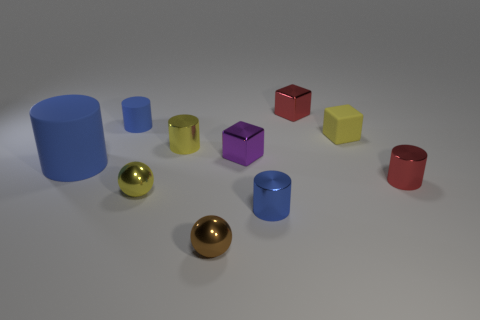Can you tell me more about the arrangement of these shapes? Certainly! The configuration of the objects seems deliberately spaced, with each shape given room to stand out. There's a mix of geometrical figures such as cubes, cylinders, and spheres. Each object showcases a different color and finish, hinting at a study of shapes, textures, and colors, possibly used to demonstrate principles of 3D modeling or artistic composition. 